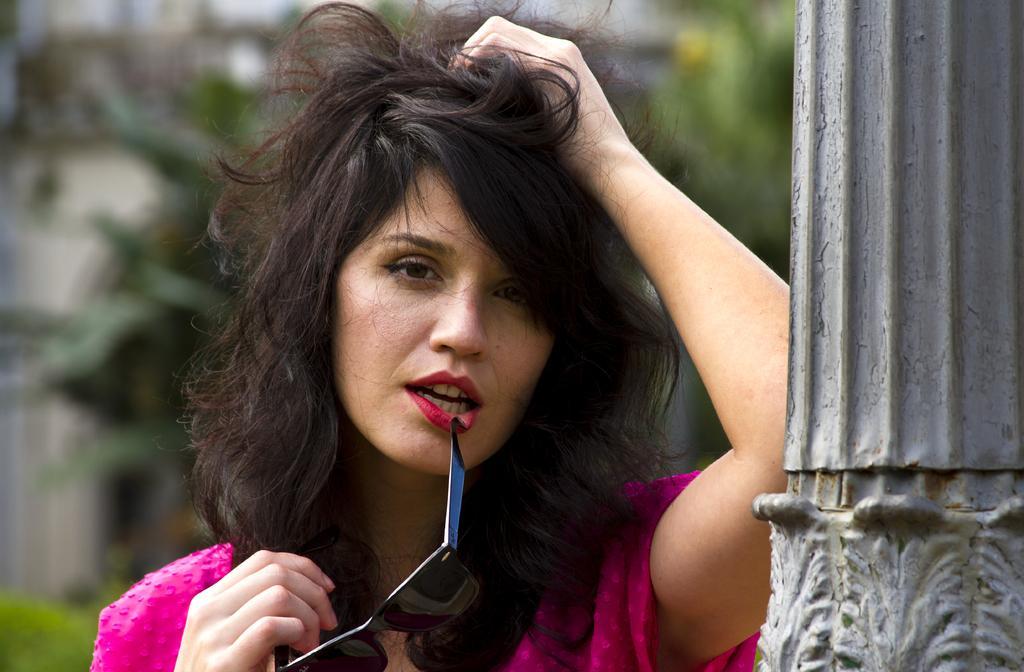How would you summarize this image in a sentence or two? In the image we can see there is a woman standing and she is holding sunglasses in her hand. She is standing beside a pillar. 